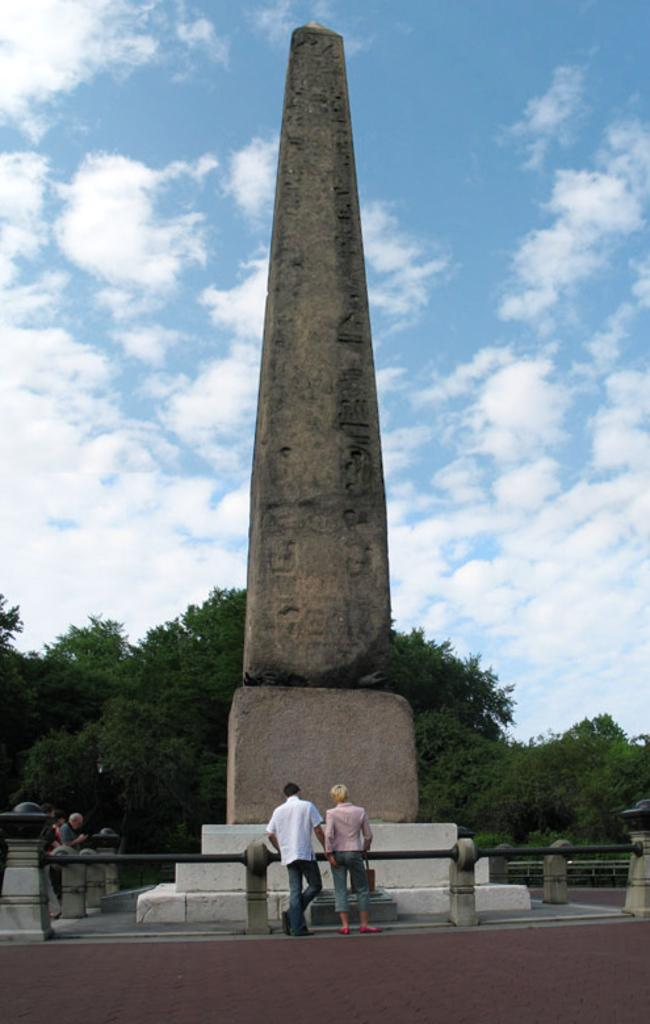What is the main structure visible in the image? There is a pillar in the image. What other objects are present near the pillar? There are rods with poles in the image. Are there any people in the image? Yes, there are people standing in the image. What is at the bottom of the image? There is a footpath at the bottom of the image. What can be seen in the background of the image? There are trees and a cloudy sky in the background of the image. What type of company is being taught by the pillar in the image? There is no company or teaching activity present in the image; it features a pillar, rods with poles, people, a footpath, trees, and a cloudy sky. 